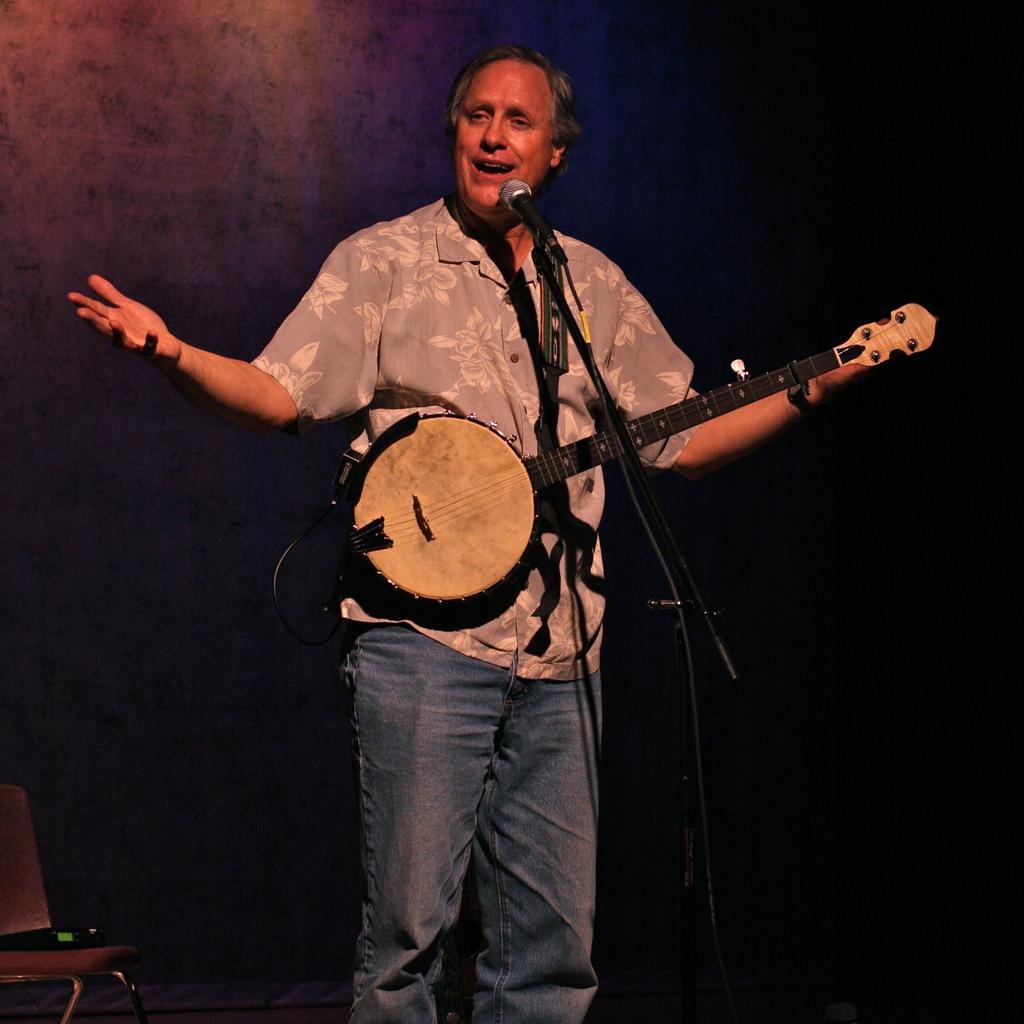Please provide a concise description of this image. In this image we can see a man standing wearing the musical instrument with a belt. We can also see a mic with a stand in front of him. On the left bottom we can see a device on a chair. 